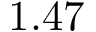<formula> <loc_0><loc_0><loc_500><loc_500>1 . 4 7</formula> 